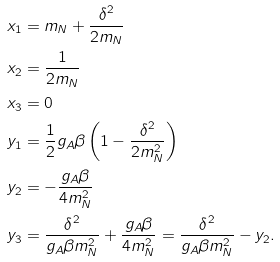<formula> <loc_0><loc_0><loc_500><loc_500>x _ { 1 } & = m _ { N } + \frac { \delta ^ { 2 } } { 2 m _ { N } } \\ x _ { 2 } & = \frac { 1 } { 2 m _ { N } } \\ x _ { 3 } & = 0 \\ y _ { 1 } & = \frac { 1 } { 2 } g _ { A } \beta \left ( 1 - \frac { \delta ^ { 2 } } { 2 m _ { N } ^ { 2 } } \right ) \\ y _ { 2 } & = - \frac { g _ { A } \beta } { 4 m _ { N } ^ { 2 } } \\ y _ { 3 } & = \frac { \delta ^ { 2 } } { g _ { A } \beta m _ { N } ^ { 2 } } + \frac { g _ { A } \beta } { 4 m _ { N } ^ { 2 } } = \frac { \delta ^ { 2 } } { g _ { A } \beta m _ { N } ^ { 2 } } - y _ { 2 } .</formula> 